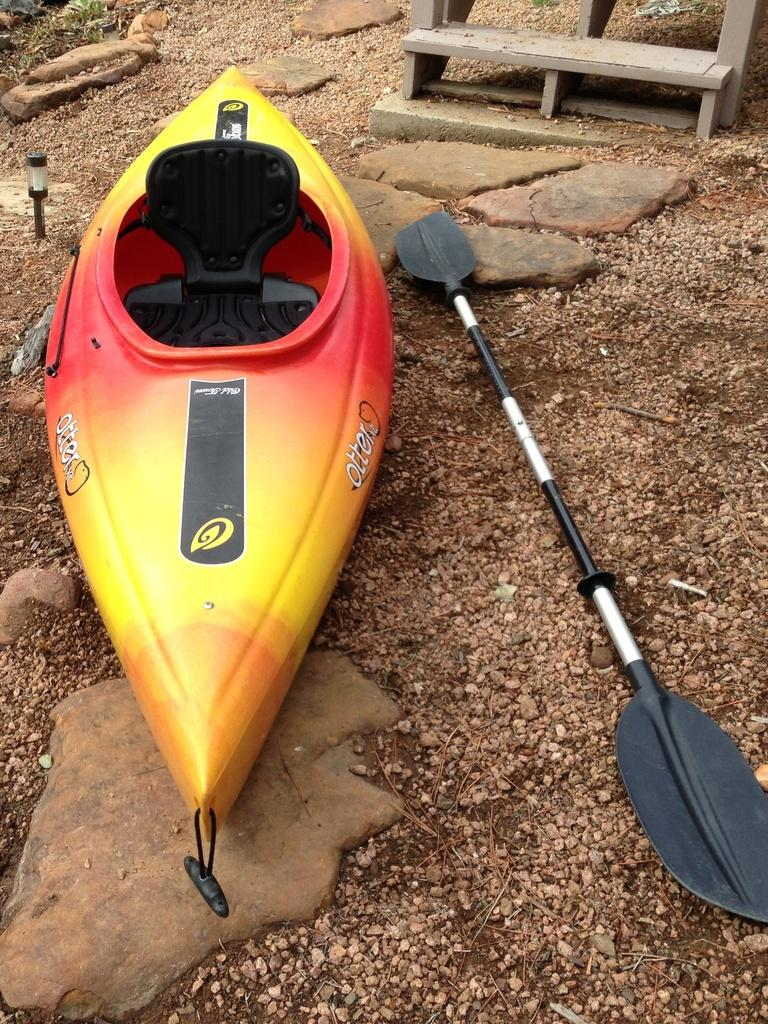What is the main subject of the image? There is a boat in the image. What else can be seen in the image besides the boat? A stick is placed on the rocks, and there are rocks in the image. What is visible in the background of the image? There is a bench in the background of the image. What type of patch can be seen on the boat in the image? There is no patch visible on the boat in the image. Is there a letter addressed to the boat in the image? There is no letter present in the image. 